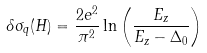<formula> <loc_0><loc_0><loc_500><loc_500>\delta \sigma _ { q } ( H ) = \frac { 2 e ^ { 2 } } { \pi ^ { 2 } } \ln \left ( \frac { E _ { z } } { E _ { z } - \Delta _ { 0 } } \right )</formula> 